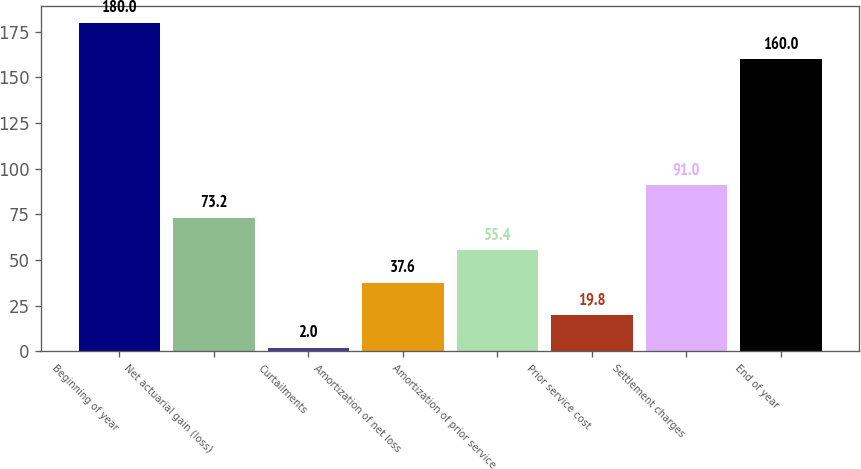<chart> <loc_0><loc_0><loc_500><loc_500><bar_chart><fcel>Beginning of year<fcel>Net actuarial gain (loss)<fcel>Curtailments<fcel>Amortization of net loss<fcel>Amortization of prior service<fcel>Prior service cost<fcel>Settlement charges<fcel>End of year<nl><fcel>180<fcel>73.2<fcel>2<fcel>37.6<fcel>55.4<fcel>19.8<fcel>91<fcel>160<nl></chart> 